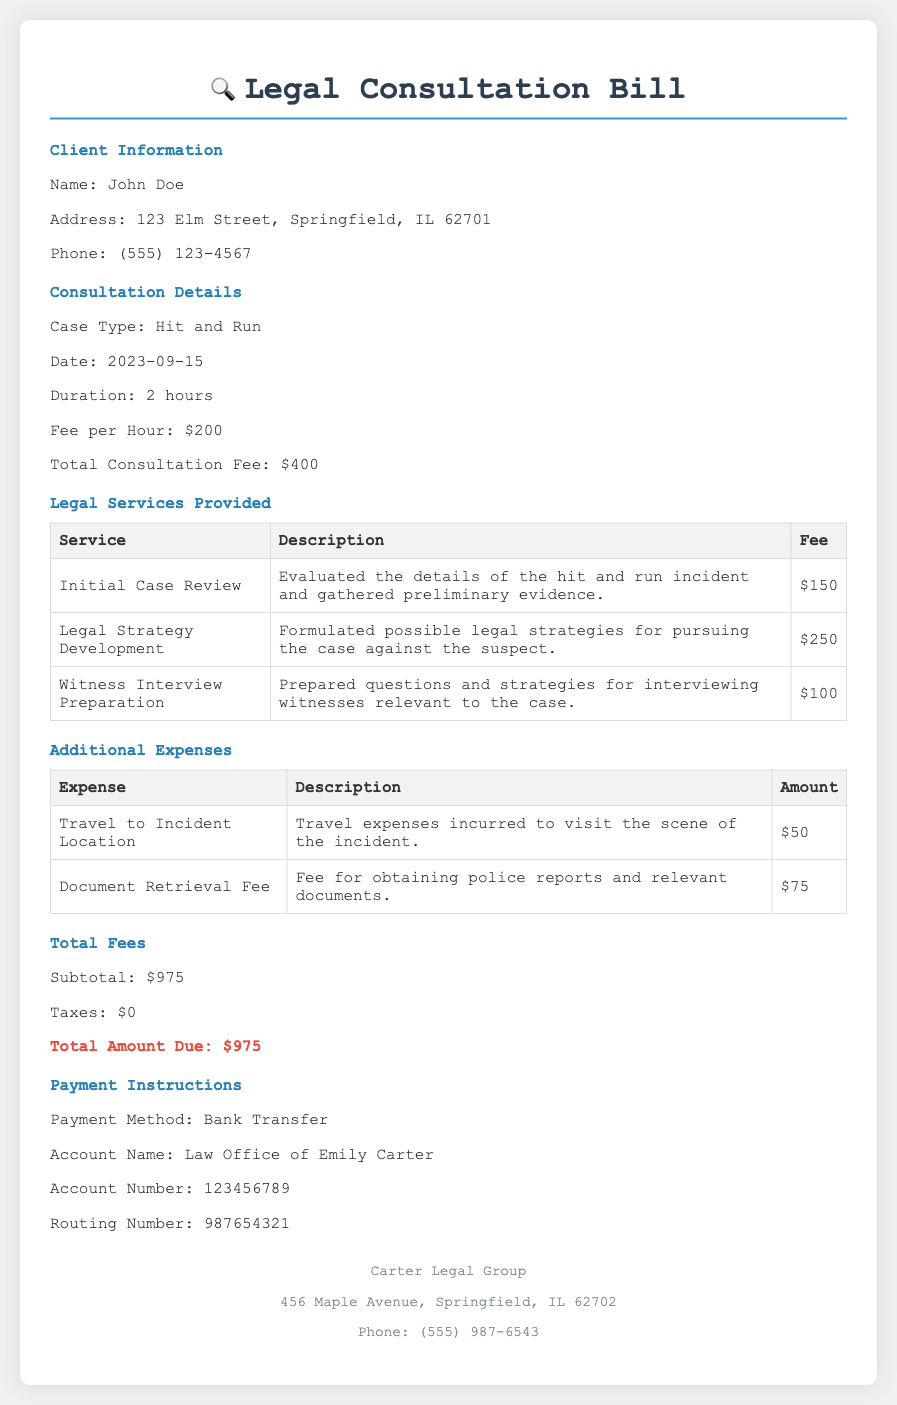What is the name of the client? The document provides the client's information, including their name, which is John Doe.
Answer: John Doe What is the case type? The document specifies the type of case that is being consulted on, which is a hit and run case.
Answer: Hit and Run What is the fee per hour for consultation? The document lists the fee for consultation per hour, which is $200.
Answer: $200 What is the total amount due? The total amount due is mentioned at the end of the document and is calculated as $975.
Answer: $975 How many hours did the consultation last? The consultation duration is stated in the document as 2 hours.
Answer: 2 hours What services are included in the bill? The legal services table lists the services provided, including Initial Case Review, Legal Strategy Development, and Witness Interview Preparation.
Answer: Initial Case Review, Legal Strategy Development, Witness Interview Preparation What is the payment method specified? The document specifies the payment method for the consultation fee, which is bank transfer.
Answer: Bank Transfer How much was spent on travel expenses? The document includes an additional expense for travel to the incident location, which amounted to $50.
Answer: $50 What date was the consultation held? The date of the consultation is listed clearly in the document as September 15, 2023.
Answer: 2023-09-15 